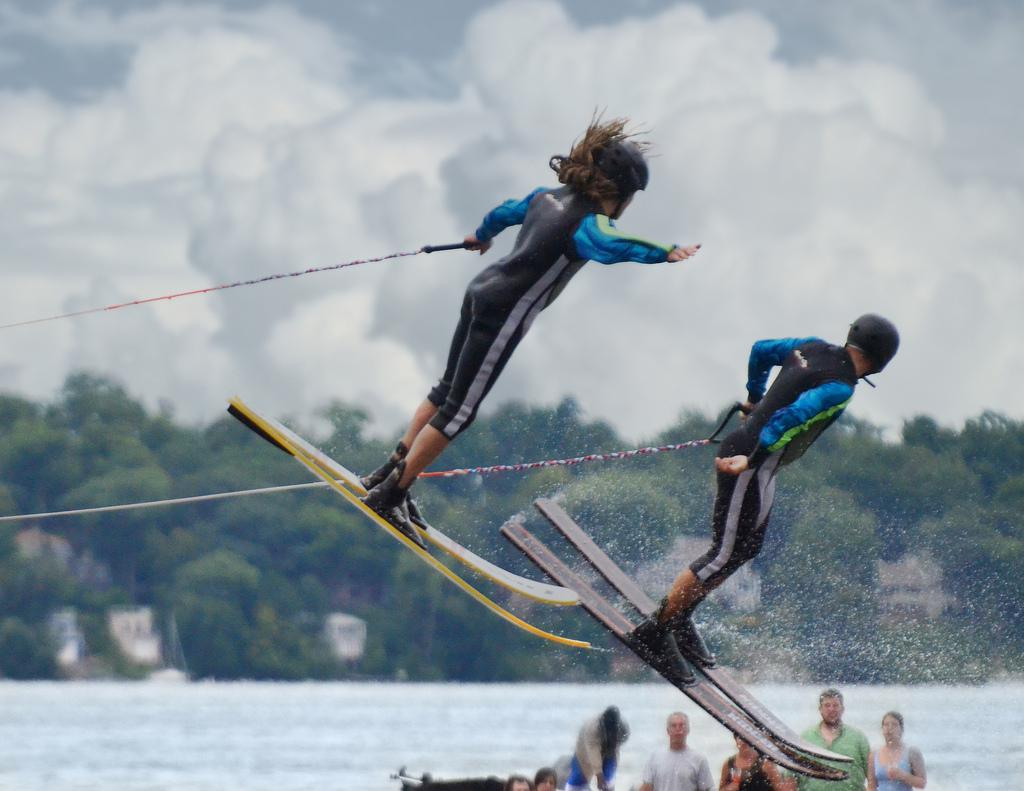Question: who is flying higher than the right skier?
Choices:
A. The snowboarder.
B. The snowmobiler.
C. The skier on the diamond pass.
D. The left skier.
Answer with the letter. Answer: D Question: who is in the picture?
Choices:
A. Surfers.
B. Mothers and daughters.
C. Fathers and sons.
D. Grandparents.
Answer with the letter. Answer: A Question: who is wearing a black helmet?
Choices:
A. Skateborders.
B. The man riding motorcycle.
C. The kid.
D. The water skiers.
Answer with the letter. Answer: D Question: how many water skiers are performing?
Choices:
A. 1.
B. 3.
C. 5.
D. 2.
Answer with the letter. Answer: D Question: what color is the sky?
Choices:
A. Red.
B. Blue.
C. Yellow.
D. Violet.
Answer with the letter. Answer: B Question: who has their hand raised up in the air?
Choices:
A. One of the water skiers.
B. The concert attendees.
C. The students.
D. The people on the ride.
Answer with the letter. Answer: A Question: what direction are the skiers facing from the boat?
Choices:
A. Left.
B. Right.
C. North.
D. Away.
Answer with the letter. Answer: D Question: what is one skier holding up?
Choices:
A. An arm.
B. A torch.
C. A cellphone.
D. A camera.
Answer with the letter. Answer: A Question: what are they looking at?
Choices:
A. The police.
B. The fire.
C. Bystanders.
D. A tornado.
Answer with the letter. Answer: C Question: who is watching the skiers?
Choices:
A. The lone man.
B. A crowd.
C. Celebrities.
D. A group of children.
Answer with the letter. Answer: B Question: what is in the scene?
Choices:
A. Trees.
B. Fruit.
C. Puffy clouds.
D. Flowers.
Answer with the letter. Answer: C Question: who has long hair?
Choices:
A. The right skier.
B. The female snowboarder.
C. The left skier.
D. The man on the ski lift.
Answer with the letter. Answer: C 